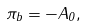<formula> <loc_0><loc_0><loc_500><loc_500>\pi _ { b } = - A _ { 0 } ,</formula> 